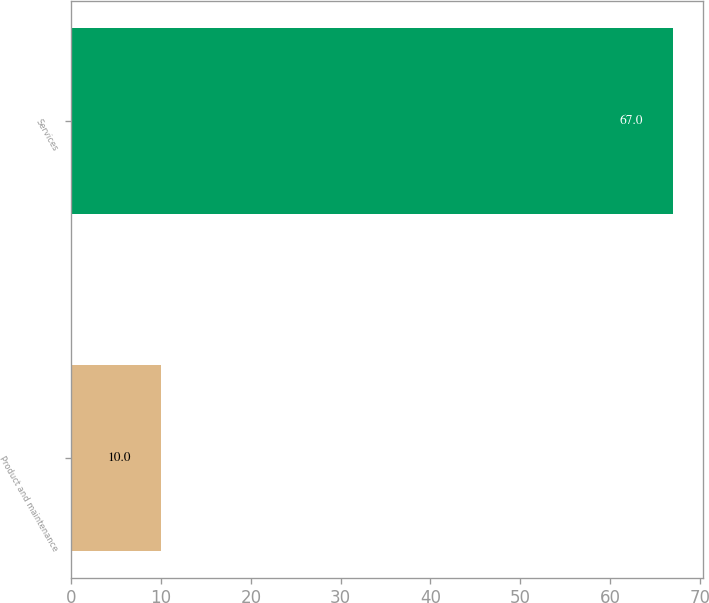Convert chart. <chart><loc_0><loc_0><loc_500><loc_500><bar_chart><fcel>Product and maintenance<fcel>Services<nl><fcel>10<fcel>67<nl></chart> 